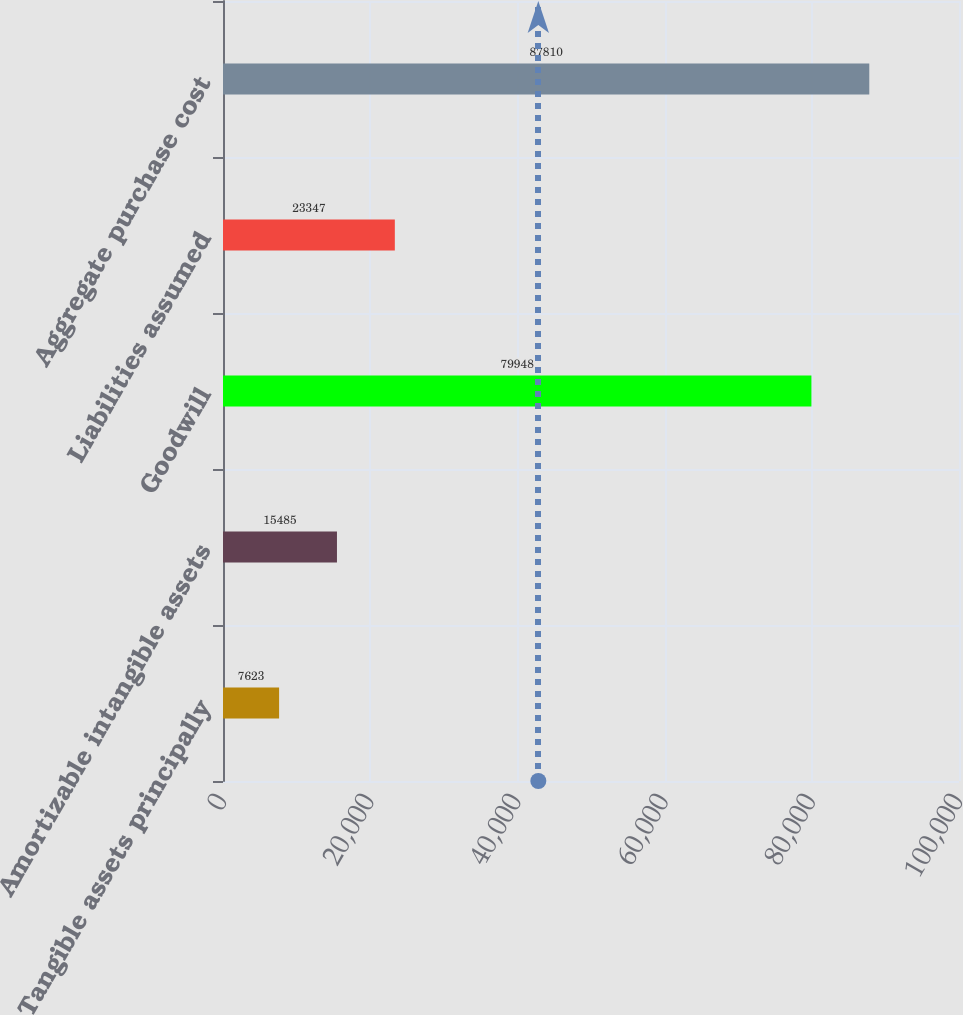<chart> <loc_0><loc_0><loc_500><loc_500><bar_chart><fcel>Tangible assets principally<fcel>Amortizable intangible assets<fcel>Goodwill<fcel>Liabilities assumed<fcel>Aggregate purchase cost<nl><fcel>7623<fcel>15485<fcel>79948<fcel>23347<fcel>87810<nl></chart> 